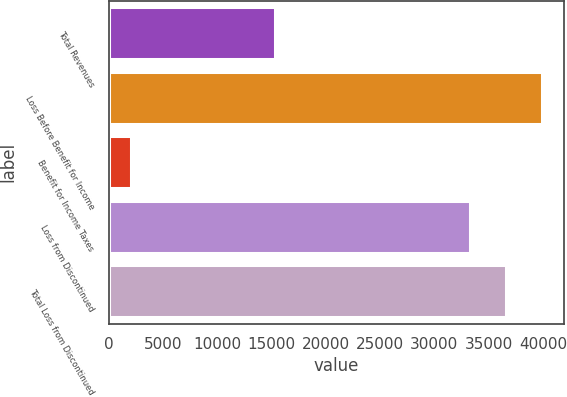Convert chart. <chart><loc_0><loc_0><loc_500><loc_500><bar_chart><fcel>Total Revenues<fcel>Loss Before Benefit for Income<fcel>Benefit for Income Taxes<fcel>Loss from Discontinued<fcel>Total Loss from Discontinued<nl><fcel>15353<fcel>39895.2<fcel>2104<fcel>33246<fcel>36570.6<nl></chart> 